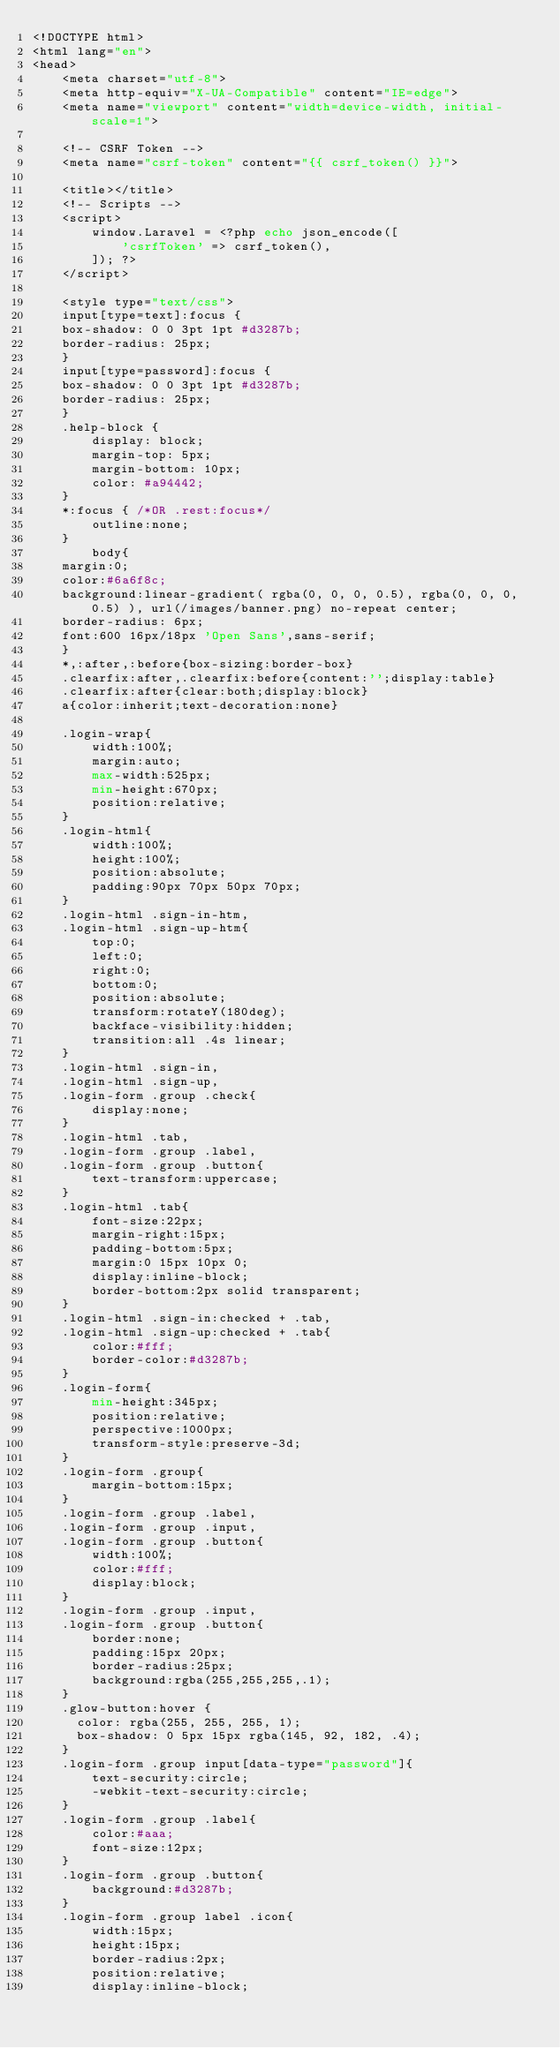<code> <loc_0><loc_0><loc_500><loc_500><_PHP_><!DOCTYPE html>
<html lang="en">
<head>
    <meta charset="utf-8">
    <meta http-equiv="X-UA-Compatible" content="IE=edge">
    <meta name="viewport" content="width=device-width, initial-scale=1">

    <!-- CSRF Token -->
    <meta name="csrf-token" content="{{ csrf_token() }}">

    <title></title>
    <!-- Scripts -->
    <script>
        window.Laravel = <?php echo json_encode([
            'csrfToken' => csrf_token(),
        ]); ?>
    </script>

    <style type="text/css">
    input[type=text]:focus {
    box-shadow: 0 0 3pt 1pt #d3287b;
    border-radius: 25px;
    }
    input[type=password]:focus {
    box-shadow: 0 0 3pt 1pt #d3287b;
    border-radius: 25px;
    }
    .help-block {
        display: block;
        margin-top: 5px;
        margin-bottom: 10px;
        color: #a94442;
    }
    *:focus { /*OR .rest:focus*/
        outline:none;
    }
        body{
    margin:0;
    color:#6a6f8c;
    background:linear-gradient( rgba(0, 0, 0, 0.5), rgba(0, 0, 0, 0.5) ), url(/images/banner.png) no-repeat center;
    border-radius: 6px;
    font:600 16px/18px 'Open Sans',sans-serif;
    }
    *,:after,:before{box-sizing:border-box}
    .clearfix:after,.clearfix:before{content:'';display:table}
    .clearfix:after{clear:both;display:block}
    a{color:inherit;text-decoration:none}

    .login-wrap{
        width:100%;
        margin:auto;
        max-width:525px;
        min-height:670px;
        position:relative;
    }
    .login-html{
        width:100%;
        height:100%;
        position:absolute;
        padding:90px 70px 50px 70px;
    }
    .login-html .sign-in-htm,
    .login-html .sign-up-htm{
        top:0;
        left:0;
        right:0;
        bottom:0;
        position:absolute;
        transform:rotateY(180deg);
        backface-visibility:hidden;
        transition:all .4s linear;
    }
    .login-html .sign-in,
    .login-html .sign-up,
    .login-form .group .check{
        display:none;
    }
    .login-html .tab,
    .login-form .group .label,
    .login-form .group .button{
        text-transform:uppercase;
    }
    .login-html .tab{
        font-size:22px;
        margin-right:15px;
        padding-bottom:5px;
        margin:0 15px 10px 0;
        display:inline-block;
        border-bottom:2px solid transparent;
    }
    .login-html .sign-in:checked + .tab,
    .login-html .sign-up:checked + .tab{
        color:#fff;
        border-color:#d3287b;
    }
    .login-form{
        min-height:345px;
        position:relative;
        perspective:1000px;
        transform-style:preserve-3d;
    }
    .login-form .group{
        margin-bottom:15px;
    }
    .login-form .group .label,
    .login-form .group .input,
    .login-form .group .button{
        width:100%;
        color:#fff;
        display:block;
    }
    .login-form .group .input,
    .login-form .group .button{
        border:none;
        padding:15px 20px;
        border-radius:25px;
        background:rgba(255,255,255,.1);
    }
    .glow-button:hover {
      color: rgba(255, 255, 255, 1);
      box-shadow: 0 5px 15px rgba(145, 92, 182, .4);
    }
    .login-form .group input[data-type="password"]{
        text-security:circle;
        -webkit-text-security:circle;
    }
    .login-form .group .label{
        color:#aaa;
        font-size:12px;
    }
    .login-form .group .button{
        background:#d3287b;
    }
    .login-form .group label .icon{
        width:15px;
        height:15px;
        border-radius:2px;
        position:relative;
        display:inline-block;</code> 